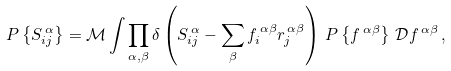Convert formula to latex. <formula><loc_0><loc_0><loc_500><loc_500>P \left \{ S _ { i j } ^ { \, \alpha } \right \} & = { \mathcal { M } } \int \prod _ { \alpha , \beta } \delta \left ( S ^ { \, \alpha } _ { i j } - \sum _ { \beta } f ^ { \, \alpha \beta } _ { i } r ^ { \, \alpha \beta } _ { j } \right ) \, P \left \{ f ^ { \, \alpha \beta } \right \} \, { \mathcal { D } } f ^ { \, \alpha \beta } \, ,</formula> 